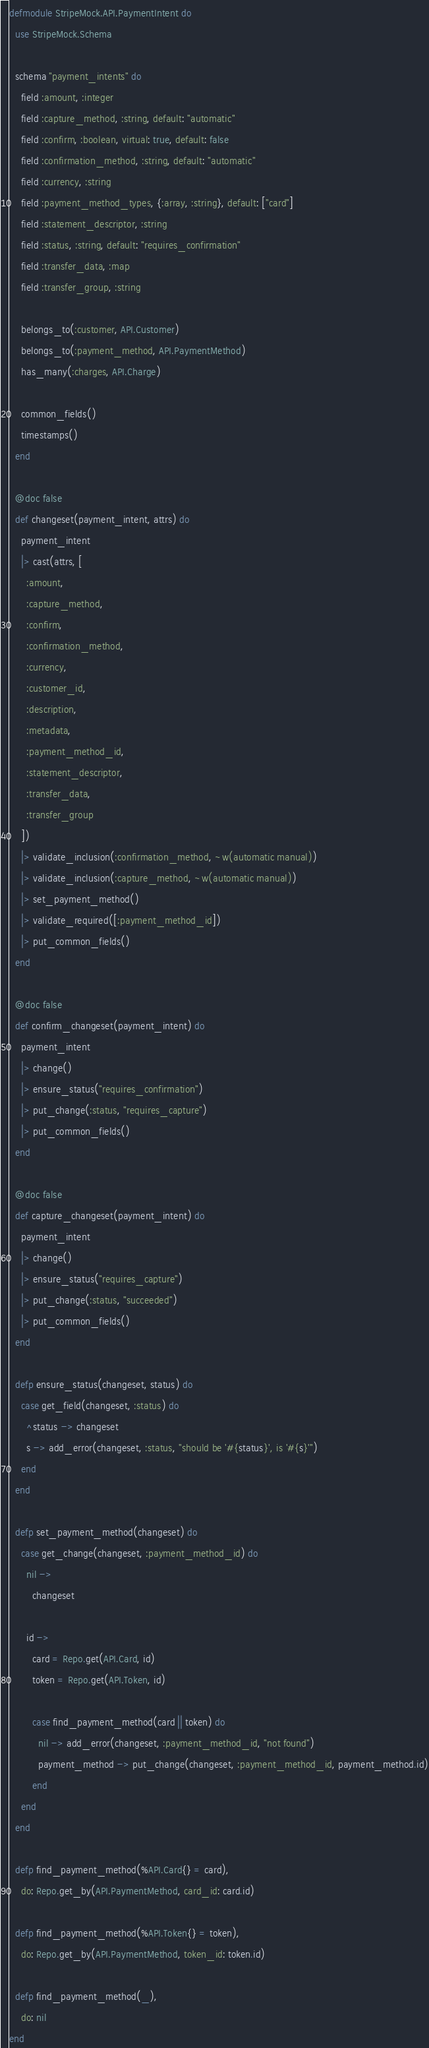<code> <loc_0><loc_0><loc_500><loc_500><_Elixir_>defmodule StripeMock.API.PaymentIntent do
  use StripeMock.Schema

  schema "payment_intents" do
    field :amount, :integer
    field :capture_method, :string, default: "automatic"
    field :confirm, :boolean, virtual: true, default: false
    field :confirmation_method, :string, default: "automatic"
    field :currency, :string
    field :payment_method_types, {:array, :string}, default: ["card"]
    field :statement_descriptor, :string
    field :status, :string, default: "requires_confirmation"
    field :transfer_data, :map
    field :transfer_group, :string

    belongs_to(:customer, API.Customer)
    belongs_to(:payment_method, API.PaymentMethod)
    has_many(:charges, API.Charge)

    common_fields()
    timestamps()
  end

  @doc false
  def changeset(payment_intent, attrs) do
    payment_intent
    |> cast(attrs, [
      :amount,
      :capture_method,
      :confirm,
      :confirmation_method,
      :currency,
      :customer_id,
      :description,
      :metadata,
      :payment_method_id,
      :statement_descriptor,
      :transfer_data,
      :transfer_group
    ])
    |> validate_inclusion(:confirmation_method, ~w(automatic manual))
    |> validate_inclusion(:capture_method, ~w(automatic manual))
    |> set_payment_method()
    |> validate_required([:payment_method_id])
    |> put_common_fields()
  end

  @doc false
  def confirm_changeset(payment_intent) do
    payment_intent
    |> change()
    |> ensure_status("requires_confirmation")
    |> put_change(:status, "requires_capture")
    |> put_common_fields()
  end

  @doc false
  def capture_changeset(payment_intent) do
    payment_intent
    |> change()
    |> ensure_status("requires_capture")
    |> put_change(:status, "succeeded")
    |> put_common_fields()
  end

  defp ensure_status(changeset, status) do
    case get_field(changeset, :status) do
      ^status -> changeset
      s -> add_error(changeset, :status, "should be '#{status}', is '#{s}'")
    end
  end

  defp set_payment_method(changeset) do
    case get_change(changeset, :payment_method_id) do
      nil ->
        changeset

      id ->
        card = Repo.get(API.Card, id)
        token = Repo.get(API.Token, id)

        case find_payment_method(card || token) do
          nil -> add_error(changeset, :payment_method_id, "not found")
          payment_method -> put_change(changeset, :payment_method_id, payment_method.id)
        end
    end
  end

  defp find_payment_method(%API.Card{} = card),
    do: Repo.get_by(API.PaymentMethod, card_id: card.id)

  defp find_payment_method(%API.Token{} = token),
    do: Repo.get_by(API.PaymentMethod, token_id: token.id)

  defp find_payment_method(_),
    do: nil
end
</code> 